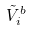Convert formula to latex. <formula><loc_0><loc_0><loc_500><loc_500>\tilde { V } _ { i } ^ { b }</formula> 